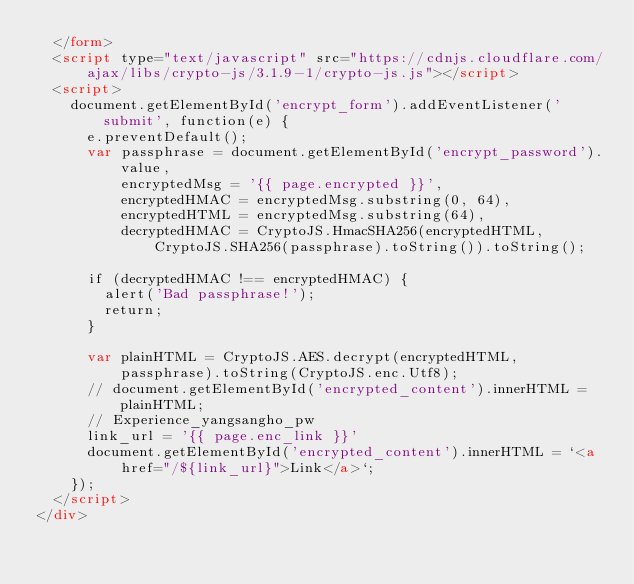<code> <loc_0><loc_0><loc_500><loc_500><_HTML_>  </form>
  <script type="text/javascript" src="https://cdnjs.cloudflare.com/ajax/libs/crypto-js/3.1.9-1/crypto-js.js"></script>
  <script>
    document.getElementById('encrypt_form').addEventListener('submit', function(e) {
      e.preventDefault();
      var passphrase = document.getElementById('encrypt_password').value,
          encryptedMsg = '{{ page.encrypted }}',
          encryptedHMAC = encryptedMsg.substring(0, 64),
          encryptedHTML = encryptedMsg.substring(64),
          decryptedHMAC = CryptoJS.HmacSHA256(encryptedHTML, CryptoJS.SHA256(passphrase).toString()).toString();

      if (decryptedHMAC !== encryptedHMAC) {
        alert('Bad passphrase!');
        return;
      }

      var plainHTML = CryptoJS.AES.decrypt(encryptedHTML, passphrase).toString(CryptoJS.enc.Utf8);
      // document.getElementById('encrypted_content').innerHTML = plainHTML;
      // Experience_yangsangho_pw
      link_url = '{{ page.enc_link }}'
      document.getElementById('encrypted_content').innerHTML = `<a href="/${link_url}">Link</a>`;
    });
  </script>
</div></code> 